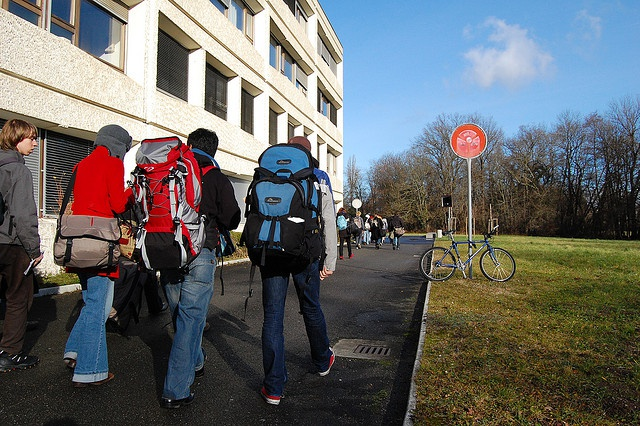Describe the objects in this image and their specific colors. I can see people in tan, black, darkgray, and gray tones, people in tan, black, blue, gray, and darkblue tones, backpack in tan, black, gray, and teal tones, backpack in tan, black, brown, and darkgray tones, and people in tan, brown, blue, and black tones in this image. 